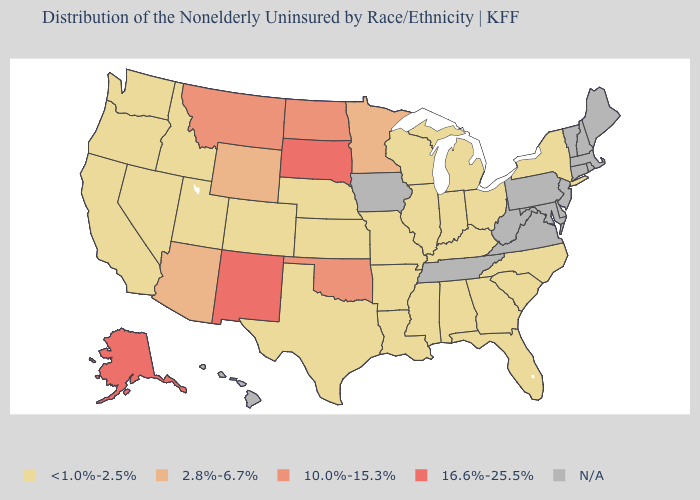What is the highest value in states that border Wisconsin?
Be succinct. 2.8%-6.7%. What is the lowest value in the West?
Quick response, please. <1.0%-2.5%. Name the states that have a value in the range <1.0%-2.5%?
Quick response, please. Alabama, Arkansas, California, Colorado, Florida, Georgia, Idaho, Illinois, Indiana, Kansas, Kentucky, Louisiana, Michigan, Mississippi, Missouri, Nebraska, Nevada, New York, North Carolina, Ohio, Oregon, South Carolina, Texas, Utah, Washington, Wisconsin. What is the highest value in the USA?
Write a very short answer. 16.6%-25.5%. Name the states that have a value in the range 2.8%-6.7%?
Write a very short answer. Arizona, Minnesota, Wyoming. Does North Dakota have the lowest value in the USA?
Keep it brief. No. Does Oklahoma have the highest value in the South?
Write a very short answer. Yes. Name the states that have a value in the range 2.8%-6.7%?
Write a very short answer. Arizona, Minnesota, Wyoming. Name the states that have a value in the range 10.0%-15.3%?
Write a very short answer. Montana, North Dakota, Oklahoma. What is the value of Colorado?
Write a very short answer. <1.0%-2.5%. Name the states that have a value in the range 10.0%-15.3%?
Write a very short answer. Montana, North Dakota, Oklahoma. Name the states that have a value in the range 16.6%-25.5%?
Keep it brief. Alaska, New Mexico, South Dakota. What is the lowest value in the Northeast?
Answer briefly. <1.0%-2.5%. Which states hav the highest value in the Northeast?
Give a very brief answer. New York. 